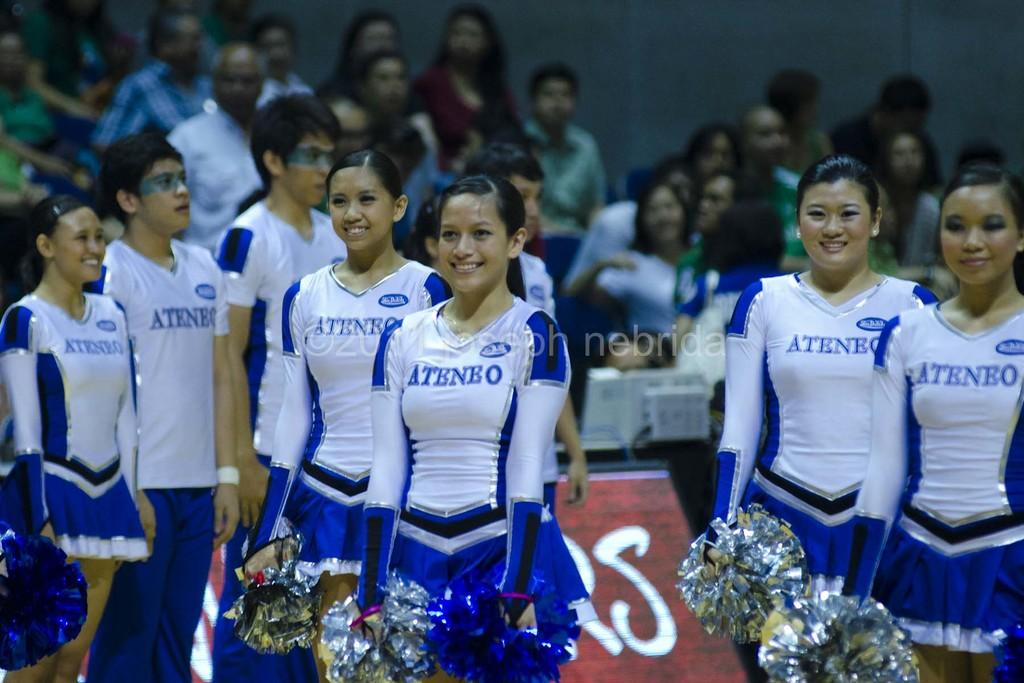<image>
Write a terse but informative summary of the picture. Team Ateneo is a competitive cheerleading group that is performing. 